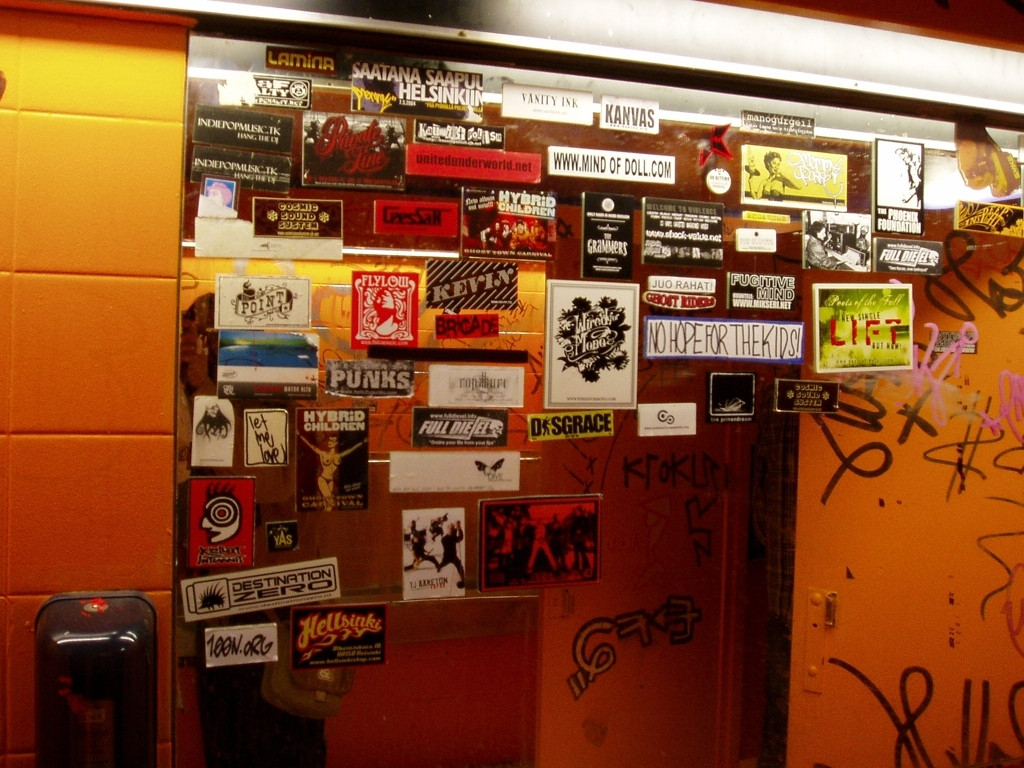What might be the significance of the repeated use of stickers as a medium of expression here? The repeated use of stickers as a medium of expression signifies a form of accessible and spontaneous street art. Stickers can be easily produced, distributed, and applied, allowing for quick dissemination of ideas, branding, or artwork. They also allow individuals to claim visual space in a public setting, enabling a form of guerrilla marketing or advocacy. The layering of stickers over time creates a visual history of the space, reflecting the changing dynamics and interests of the community that interacts with it. 